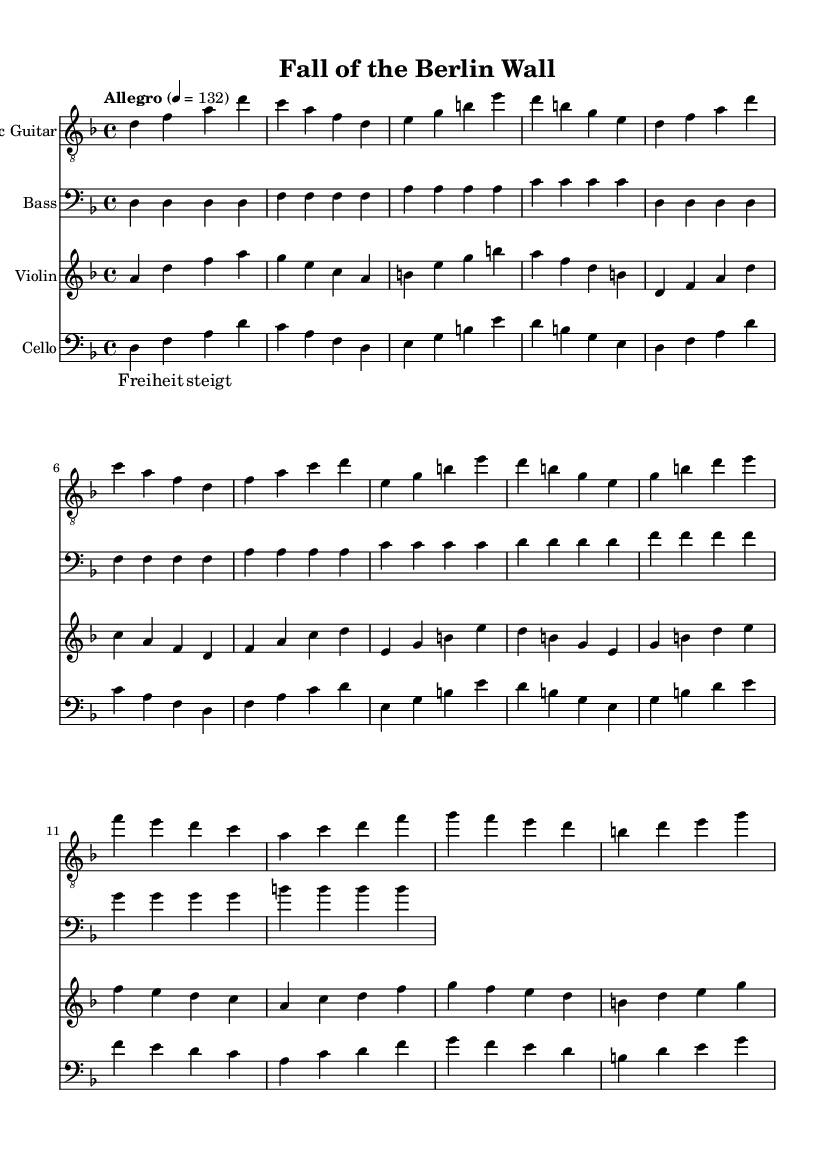What is the key signature of this music? The key signature is indicated at the beginning of the score. It shows two flats, which corresponds to the key of D minor.
Answer: D minor What is the time signature of this music? The time signature is displayed at the beginning of the piece as a fraction. It shows 4 over 4, indicating common time.
Answer: 4/4 What is the tempo marking of this piece? The tempo marking is found at the start of the score, specifying the speed of the piece. It states "Allegro" with a metronome marking of 132 beats per minute.
Answer: Allegro, 132 How many musical staves are included in the score? The number of musical staves can be counted from the score layout. There are four staves: electric guitar, bass, violin, and cello.
Answer: Four What genre does this music represent? The style reflected in the instrumentation and composition elements characterizes it as metal, particularly symphonic metal as it incorporates classical instruments like the violin and cello alongside electric guitar.
Answer: Symphonic metal Which instrument has the highest range in this piece? By analyzing the provided music lines, the electric guitar is in the treble clef and typically plays higher notes than the other instruments, thus having the highest range.
Answer: Electric guitar What is the significance of the lyrics in this piece? The lyrics "Freiheit steigt" can be analyzed contextually; they translate to "Freedom rises," which relates to the historical event represented, giving a strong thematic connection to the fall of the Berlin Wall.
Answer: Freedom 